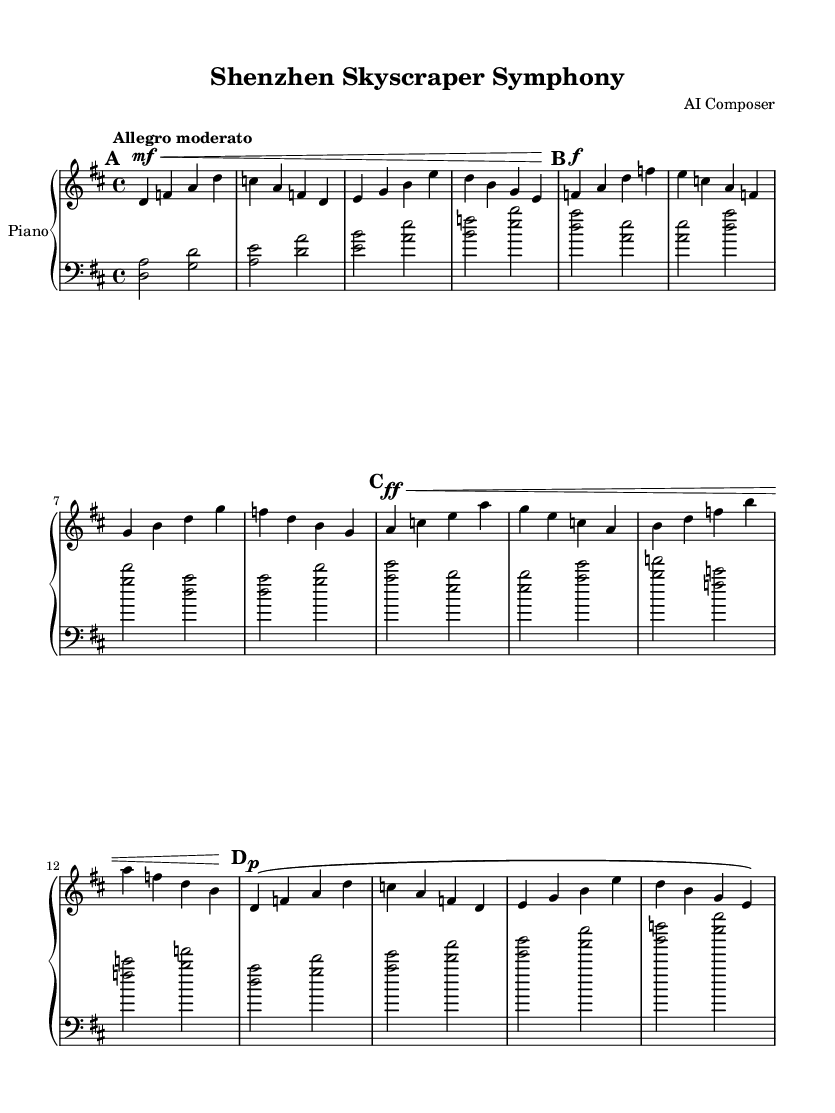What is the key signature of this music? The key signature is D major, which has two sharps (F# and C#).
Answer: D major What is the time signature of this music? The time signature is 4/4, indicating four beats per measure.
Answer: 4/4 What is the tempo marking given in the music? The tempo marking is "Allegro moderato," indicating a moderately fast tempo.
Answer: Allegro moderato How many sections are there in the piece? The piece contains four sections labeled as A, B, C, and A double-prime (A'').
Answer: Four Which section has the loudest dynamics? Section C features the loudest dynamics marked as fortissimo (ff).
Answer: Section C What is the dynamic marking of the first section? The dynamic marking is mezzo forte (mf), indicating a moderately loud volume.
Answer: Mezzo forte Which musical element indicates a return to the initial theme? The use of A double-prime (A'') indicates a return to the initial theme from section A.
Answer: A double-prime 